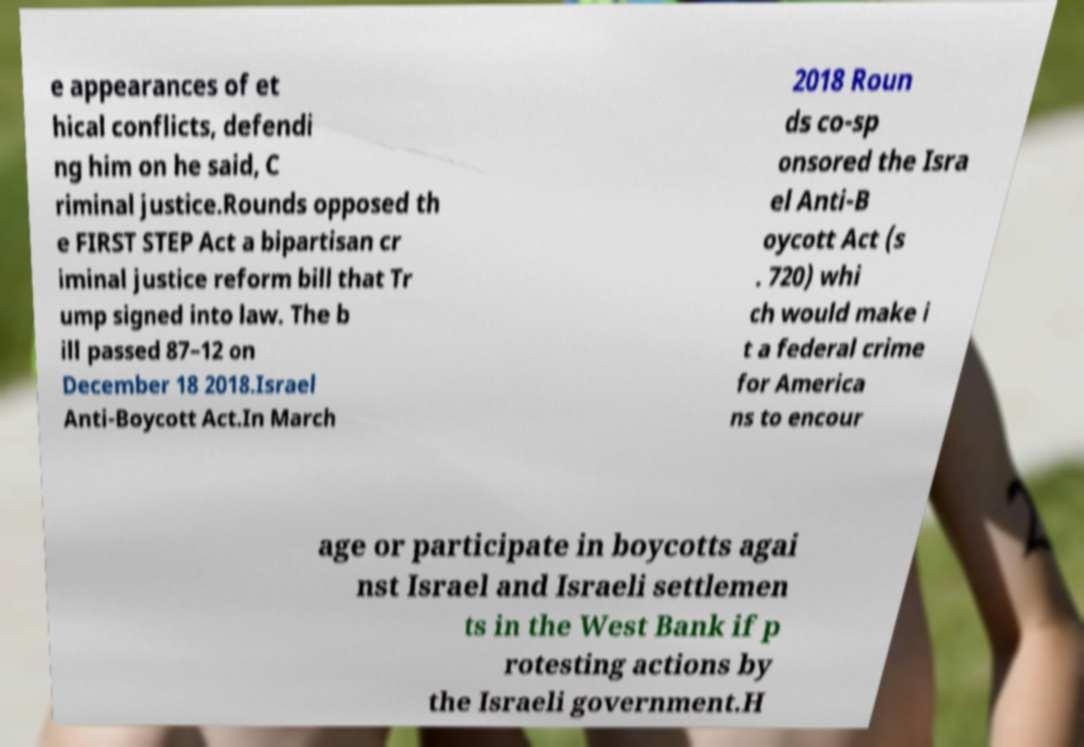Could you extract and type out the text from this image? e appearances of et hical conflicts, defendi ng him on he said, C riminal justice.Rounds opposed th e FIRST STEP Act a bipartisan cr iminal justice reform bill that Tr ump signed into law. The b ill passed 87–12 on December 18 2018.Israel Anti-Boycott Act.In March 2018 Roun ds co-sp onsored the Isra el Anti-B oycott Act (s . 720) whi ch would make i t a federal crime for America ns to encour age or participate in boycotts agai nst Israel and Israeli settlemen ts in the West Bank if p rotesting actions by the Israeli government.H 